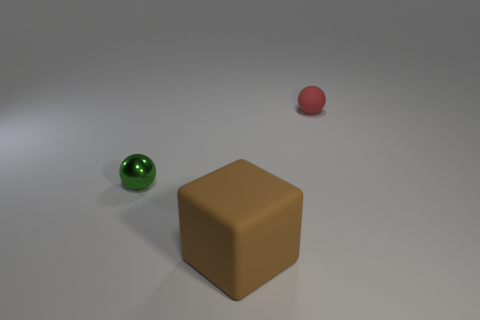What materials do the objects in the image seem to be made from, based on their appearance? Based on their appearance, the cube looks like it might be made of a matte plastic or painted wood due to its opaque surface, while the rubber ball, with its shinier, smoother surface, likely indicates it's made of rubber or a similar material. 